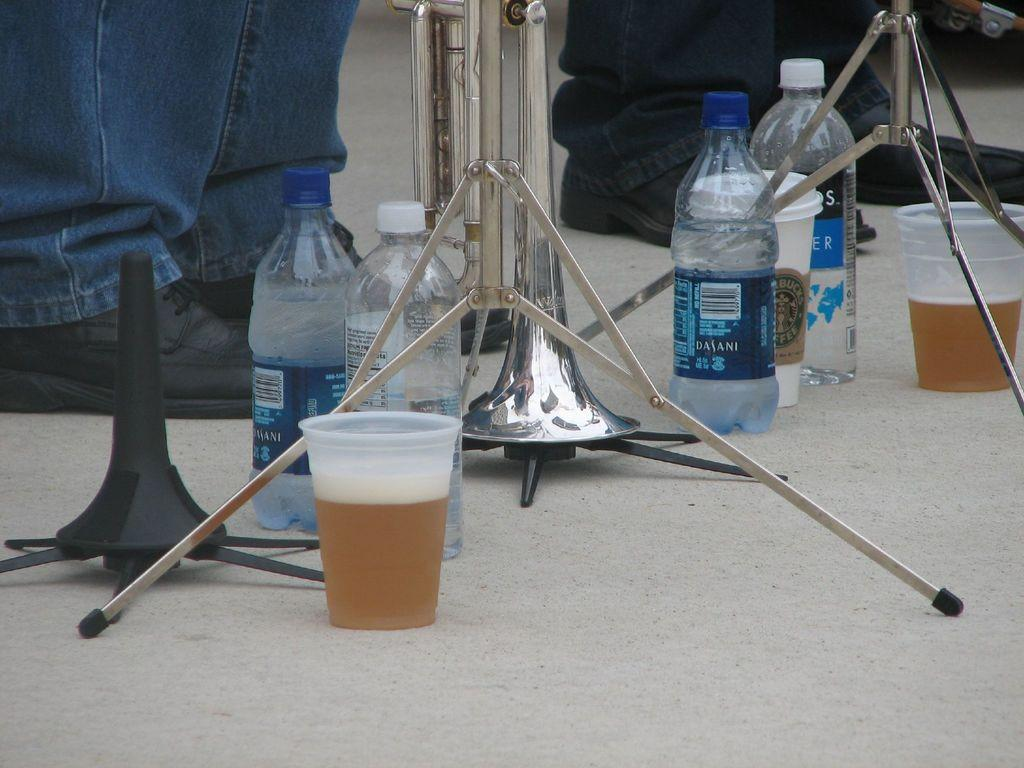Provide a one-sentence caption for the provided image. Multiple cups and bottles on the floor with a Dasani water bottle filled beside an emptier bottle. 